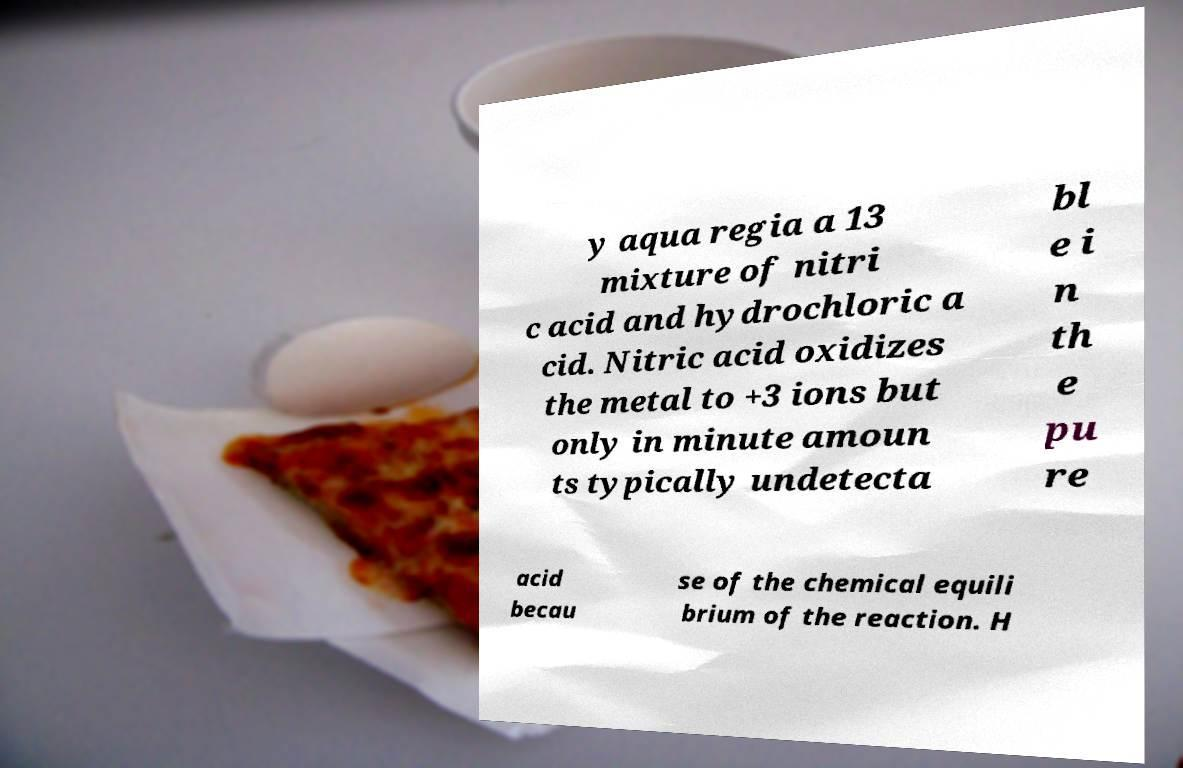Could you extract and type out the text from this image? y aqua regia a 13 mixture of nitri c acid and hydrochloric a cid. Nitric acid oxidizes the metal to +3 ions but only in minute amoun ts typically undetecta bl e i n th e pu re acid becau se of the chemical equili brium of the reaction. H 